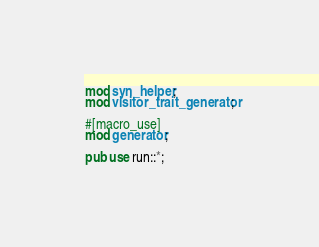Convert code to text. <code><loc_0><loc_0><loc_500><loc_500><_Rust_>mod syn_helper;
mod visitor_trait_generator;

#[macro_use]
mod generator;

pub use run::*;
</code> 